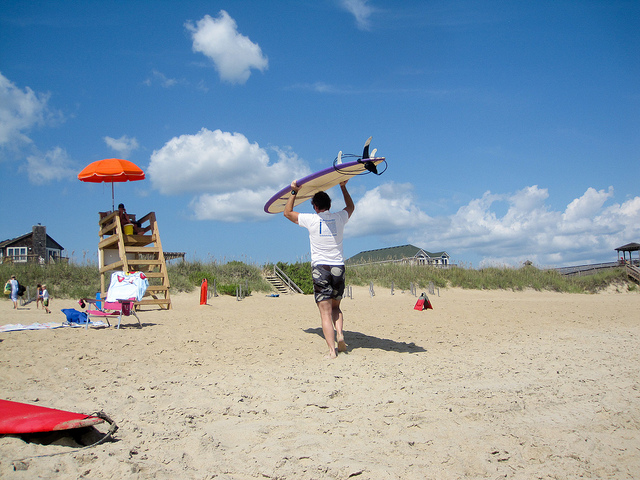How many surfboards can you see? There are two surfboards visible in the image. One is being carried by a person walking towards the ocean, and the other one is lying on the sand closer to the foreground. Both boards show off their colorful designs, hinting at the vibrant surf culture that's often associated with sunny beach days. 